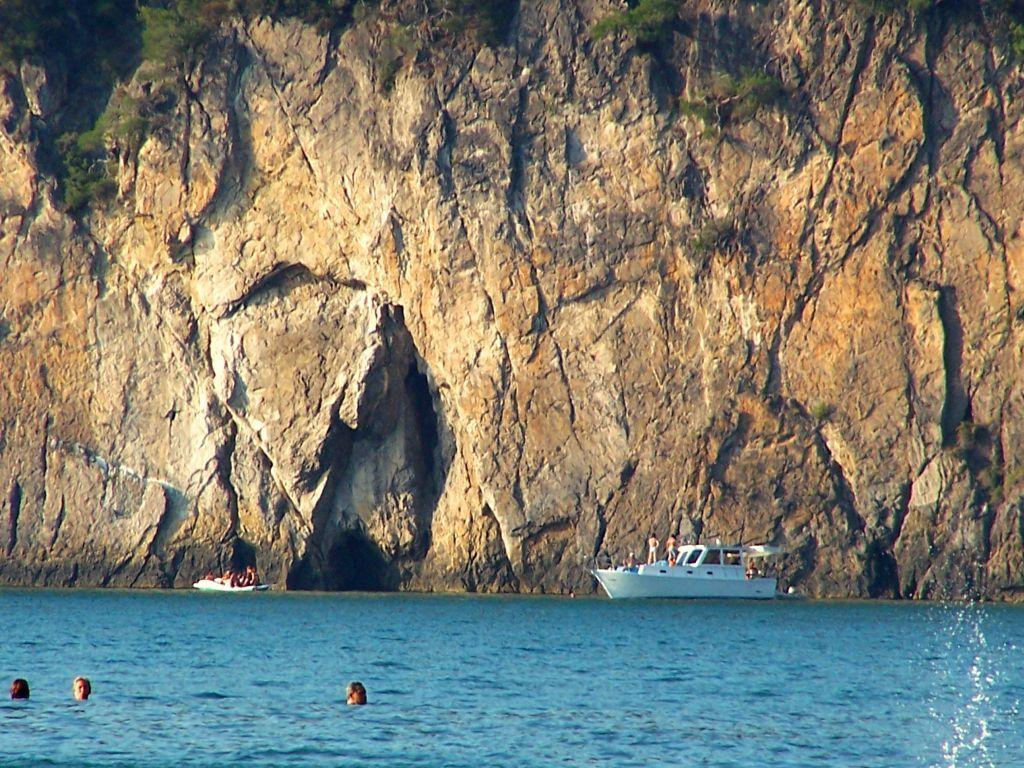What type of natural formations can be seen in the image? There are rocks in the image. What other natural elements are present in the image? There are trees in the image. What man-made objects can be seen in the image? There are ships in the image. Are there any living beings visible in the image? Yes, there are people in the image. What is the primary feature at the bottom of the image? There is water visible at the bottom of the image. Are there any people located near the water? Yes, there are persons at the bottom of the image. What type of clock is hanging from the tree in the image? There is no clock present in the image; it features rocks, trees, ships, people, and water. Can you tell me how many carts are visible in the image? There are no carts present in the image. 